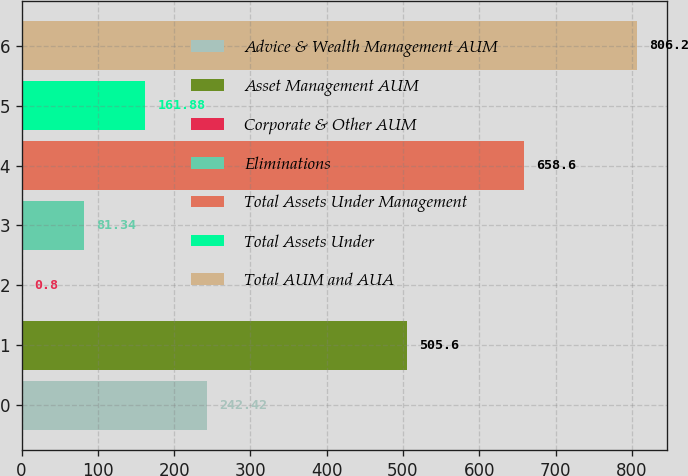<chart> <loc_0><loc_0><loc_500><loc_500><bar_chart><fcel>Advice & Wealth Management AUM<fcel>Asset Management AUM<fcel>Corporate & Other AUM<fcel>Eliminations<fcel>Total Assets Under Management<fcel>Total Assets Under<fcel>Total AUM and AUA<nl><fcel>242.42<fcel>505.6<fcel>0.8<fcel>81.34<fcel>658.6<fcel>161.88<fcel>806.2<nl></chart> 